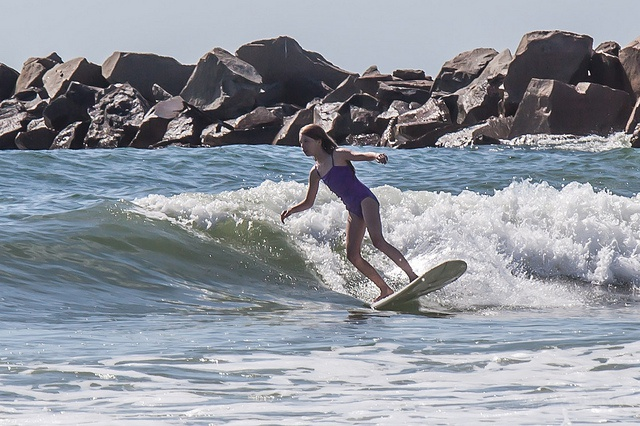Describe the objects in this image and their specific colors. I can see people in lightgray, gray, navy, and black tones and surfboard in lightgray, gray, and black tones in this image. 